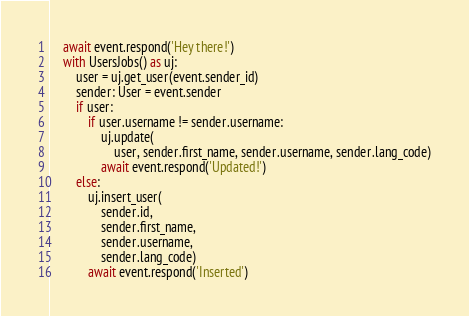Convert code to text. <code><loc_0><loc_0><loc_500><loc_500><_Python_>    await event.respond('Hey there!')
    with UsersJobs() as uj:
        user = uj.get_user(event.sender_id)
        sender: User = event.sender
        if user:
            if user.username != sender.username:
                uj.update(
                    user, sender.first_name, sender.username, sender.lang_code)
                await event.respond('Updated!')
        else:
            uj.insert_user(
                sender.id,
                sender.first_name,
                sender.username,
                sender.lang_code)
            await event.respond('Inserted')
</code> 